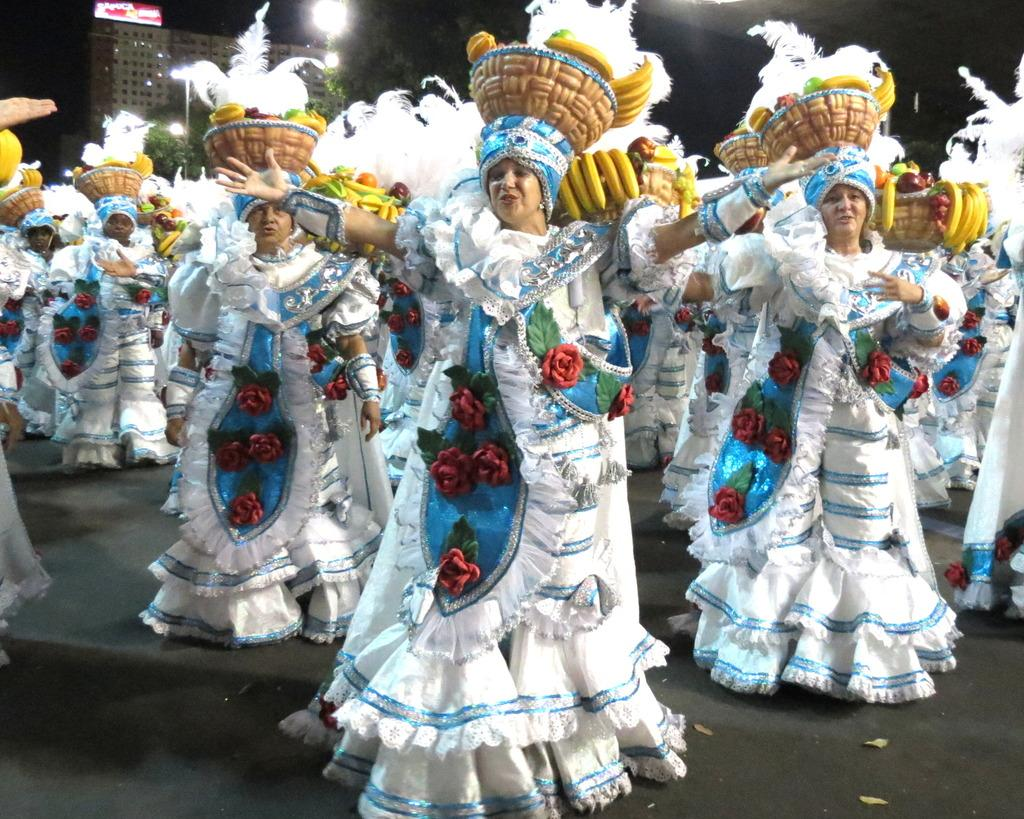How many women are present in the image? There are multiple women in the image. What are the women wearing? The women are wearing similar costumes. What are the women doing in the image? The women are singing a song and dancing. Can you describe the location of the image? The location is a specific place. What can be seen in the distance in the image? There are lights visible in the distance. Can you see any deer or kitties in the image? No, there are no deer or kitties present in the image. What color is the eye of the woman in the center of the image? There is no mention of an eye or a specific woman in the center of the image, so we cannot answer this question. 